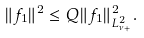Convert formula to latex. <formula><loc_0><loc_0><loc_500><loc_500>\| f _ { 1 } \| ^ { 2 } \leq Q \| f _ { 1 } \| _ { L _ { \nu _ { + } } ^ { 2 } } ^ { 2 } .</formula> 